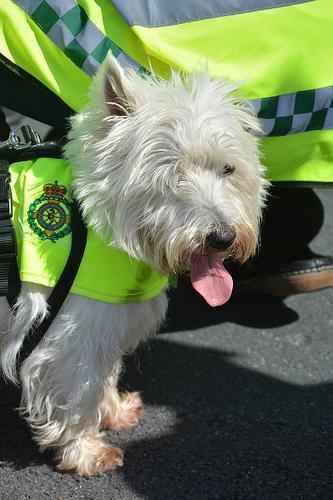How many animals are in the photo?
Give a very brief answer. 1. 